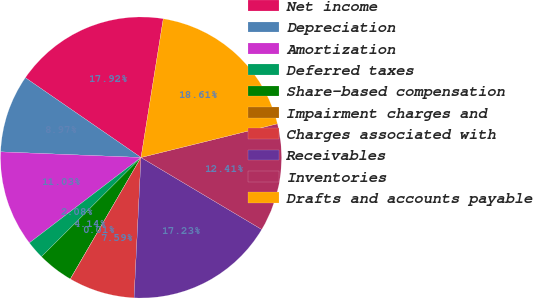<chart> <loc_0><loc_0><loc_500><loc_500><pie_chart><fcel>Net income<fcel>Depreciation<fcel>Amortization<fcel>Deferred taxes<fcel>Share-based compensation<fcel>Impairment charges and<fcel>Charges associated with<fcel>Receivables<fcel>Inventories<fcel>Drafts and accounts payable<nl><fcel>17.92%<fcel>8.97%<fcel>11.03%<fcel>2.08%<fcel>4.14%<fcel>0.01%<fcel>7.59%<fcel>17.23%<fcel>12.41%<fcel>18.61%<nl></chart> 